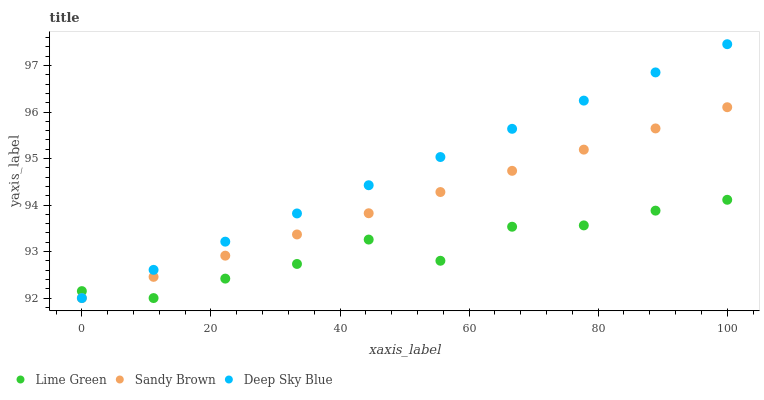Does Lime Green have the minimum area under the curve?
Answer yes or no. Yes. Does Deep Sky Blue have the maximum area under the curve?
Answer yes or no. Yes. Does Deep Sky Blue have the minimum area under the curve?
Answer yes or no. No. Does Lime Green have the maximum area under the curve?
Answer yes or no. No. Is Sandy Brown the smoothest?
Answer yes or no. Yes. Is Lime Green the roughest?
Answer yes or no. Yes. Is Deep Sky Blue the smoothest?
Answer yes or no. No. Is Deep Sky Blue the roughest?
Answer yes or no. No. Does Sandy Brown have the lowest value?
Answer yes or no. Yes. Does Deep Sky Blue have the highest value?
Answer yes or no. Yes. Does Lime Green have the highest value?
Answer yes or no. No. Does Sandy Brown intersect Lime Green?
Answer yes or no. Yes. Is Sandy Brown less than Lime Green?
Answer yes or no. No. Is Sandy Brown greater than Lime Green?
Answer yes or no. No. 